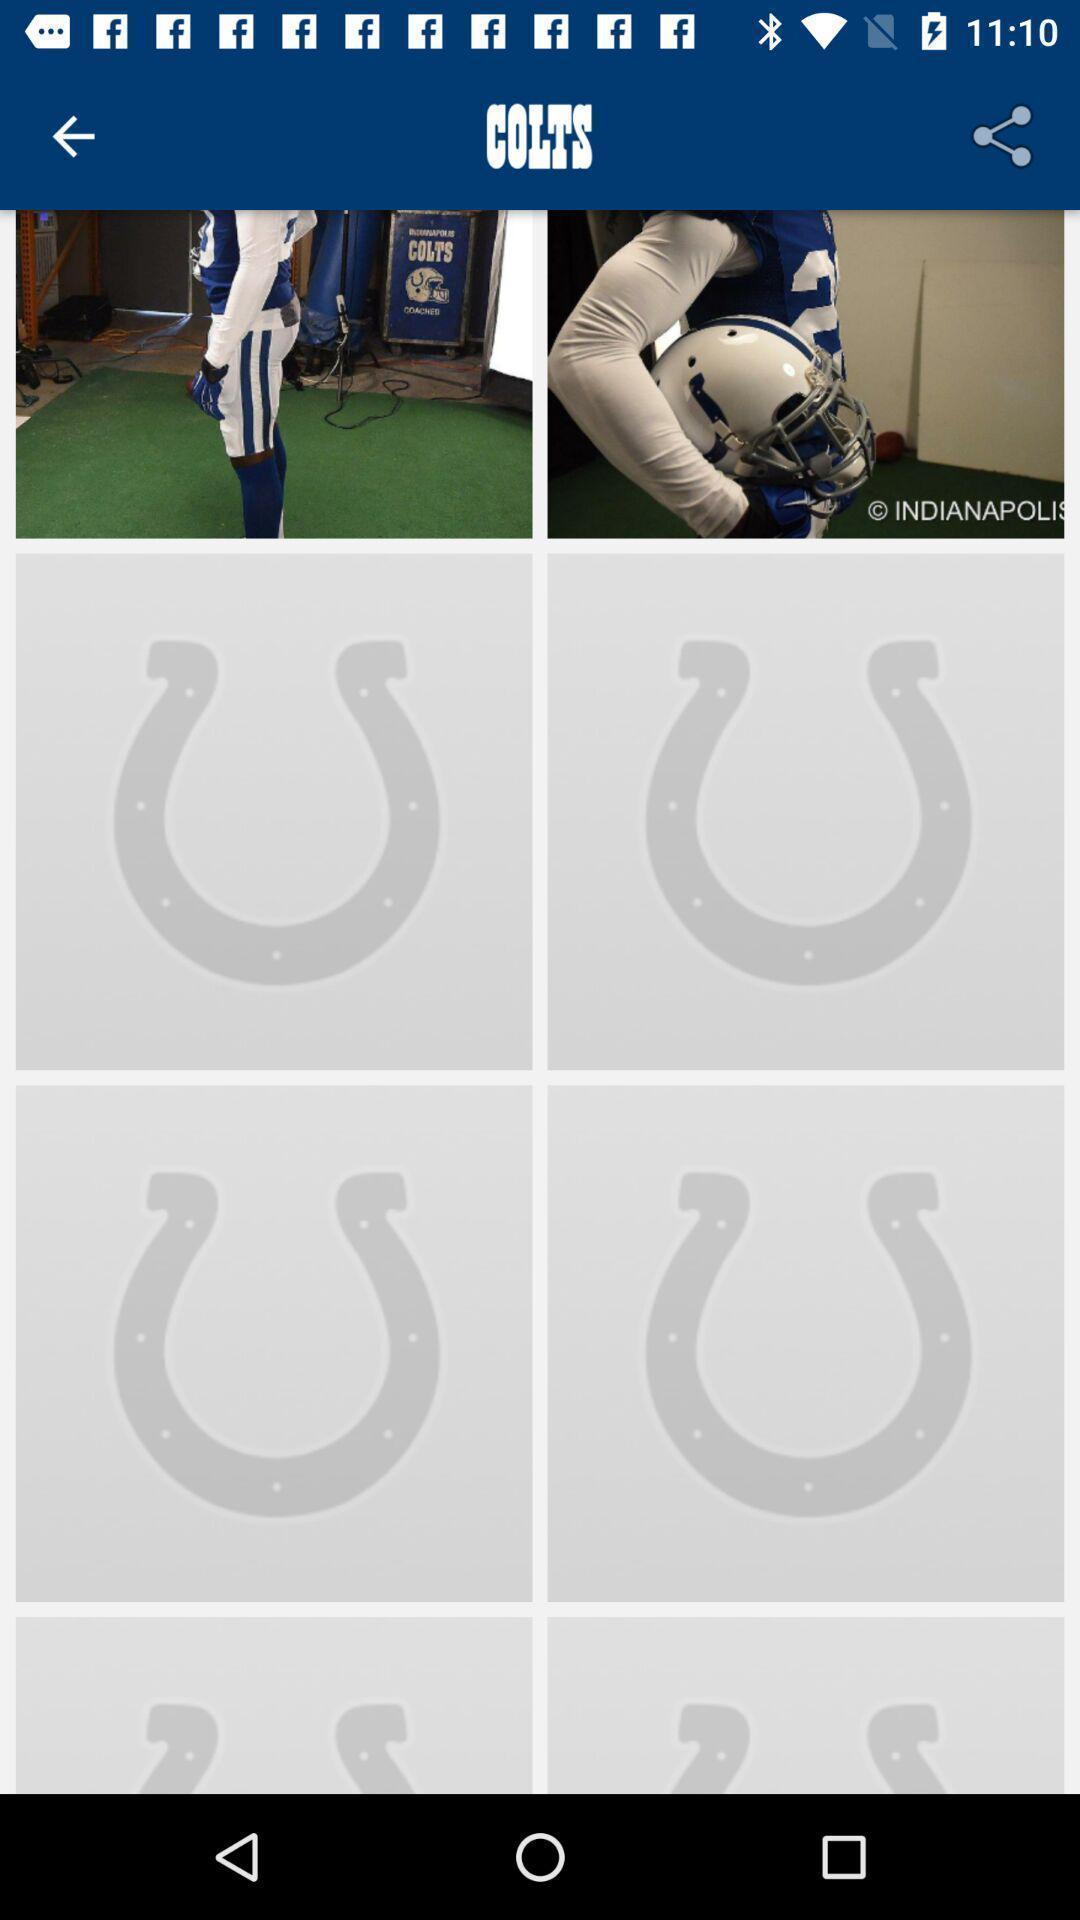Tell me what you see in this picture. Screen displaying images of sports person. 